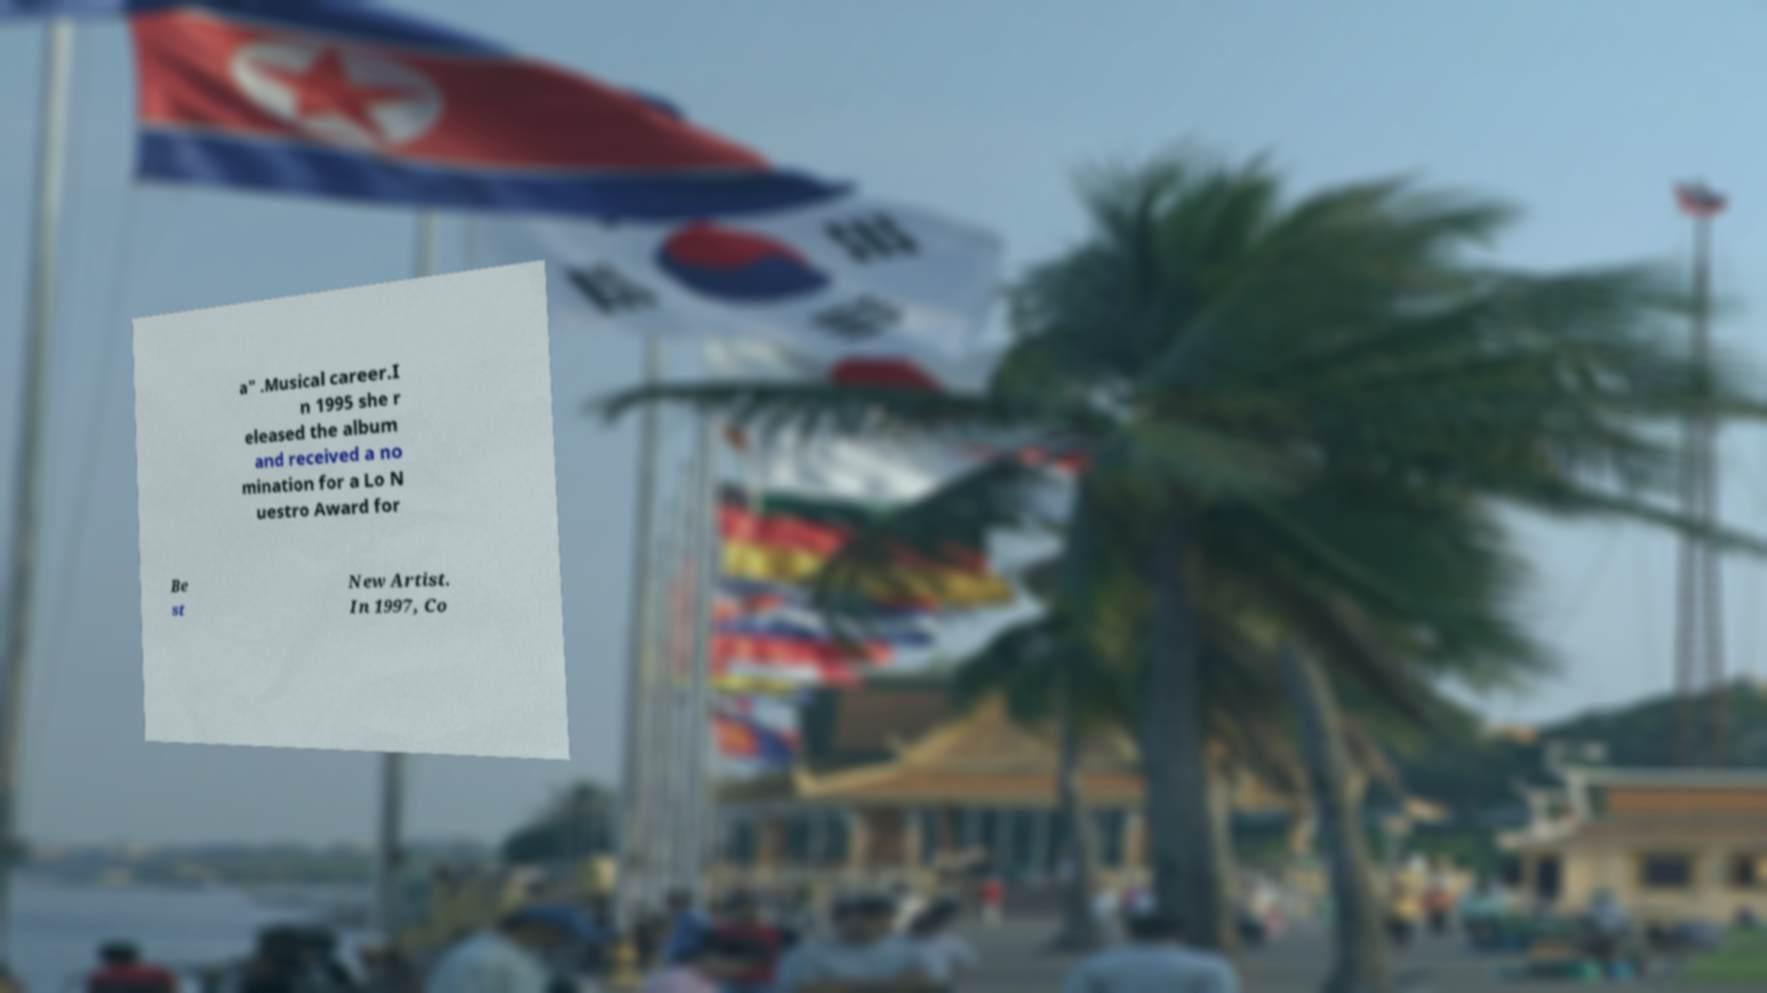For documentation purposes, I need the text within this image transcribed. Could you provide that? a" .Musical career.I n 1995 she r eleased the album and received a no mination for a Lo N uestro Award for Be st New Artist. In 1997, Co 